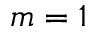<formula> <loc_0><loc_0><loc_500><loc_500>m = 1</formula> 